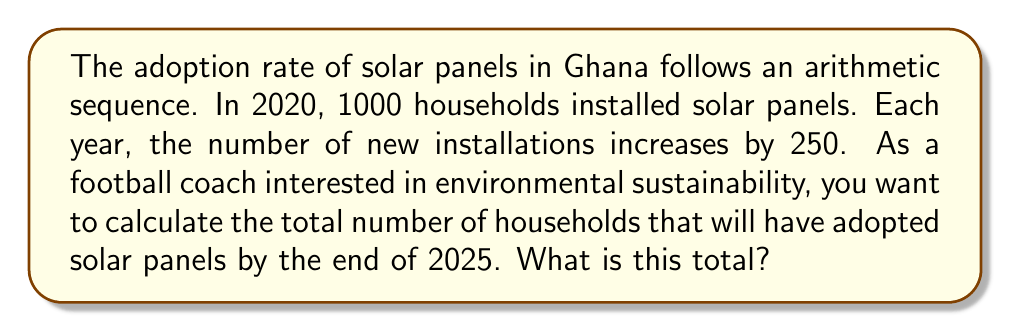Can you solve this math problem? Let's approach this step-by-step:

1) First, we need to identify the arithmetic sequence:
   - Initial term (2020): $a_1 = 1000$
   - Common difference: $d = 250$

2) We need to find the number of new installations for each year from 2020 to 2025:
   2020: $a_1 = 1000$
   2021: $a_2 = a_1 + d = 1000 + 250 = 1250$
   2022: $a_3 = a_2 + d = 1250 + 250 = 1500$
   2023: $a_4 = a_3 + d = 1500 + 250 = 1750$
   2024: $a_5 = a_4 + d = 1750 + 250 = 2000$
   2025: $a_6 = a_5 + d = 2000 + 250 = 2250$

3) To find the total number of households, we need to sum these values:

   $S_6 = a_1 + a_2 + a_3 + a_4 + a_5 + a_6$

4) We can use the arithmetic sequence sum formula:

   $S_n = \frac{n}{2}(a_1 + a_n)$

   Where $n$ is the number of terms (6 in this case), $a_1$ is the first term (1000), and $a_n$ is the last term (2250).

5) Substituting these values:

   $S_6 = \frac{6}{2}(1000 + 2250) = 3(3250) = 9750$

Therefore, by the end of 2025, a total of 9750 households will have adopted solar panels.
Answer: 9750 households 